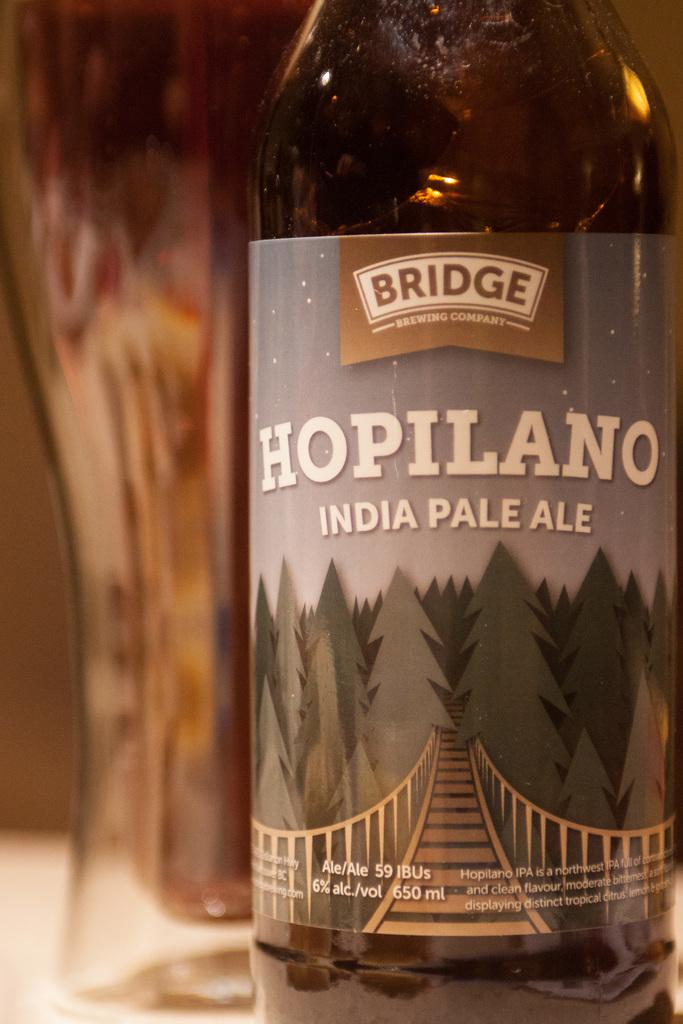<image>
Offer a succinct explanation of the picture presented. A Hopilano India Pale Ale in a bottle created by the Bridge Brewing Company. 